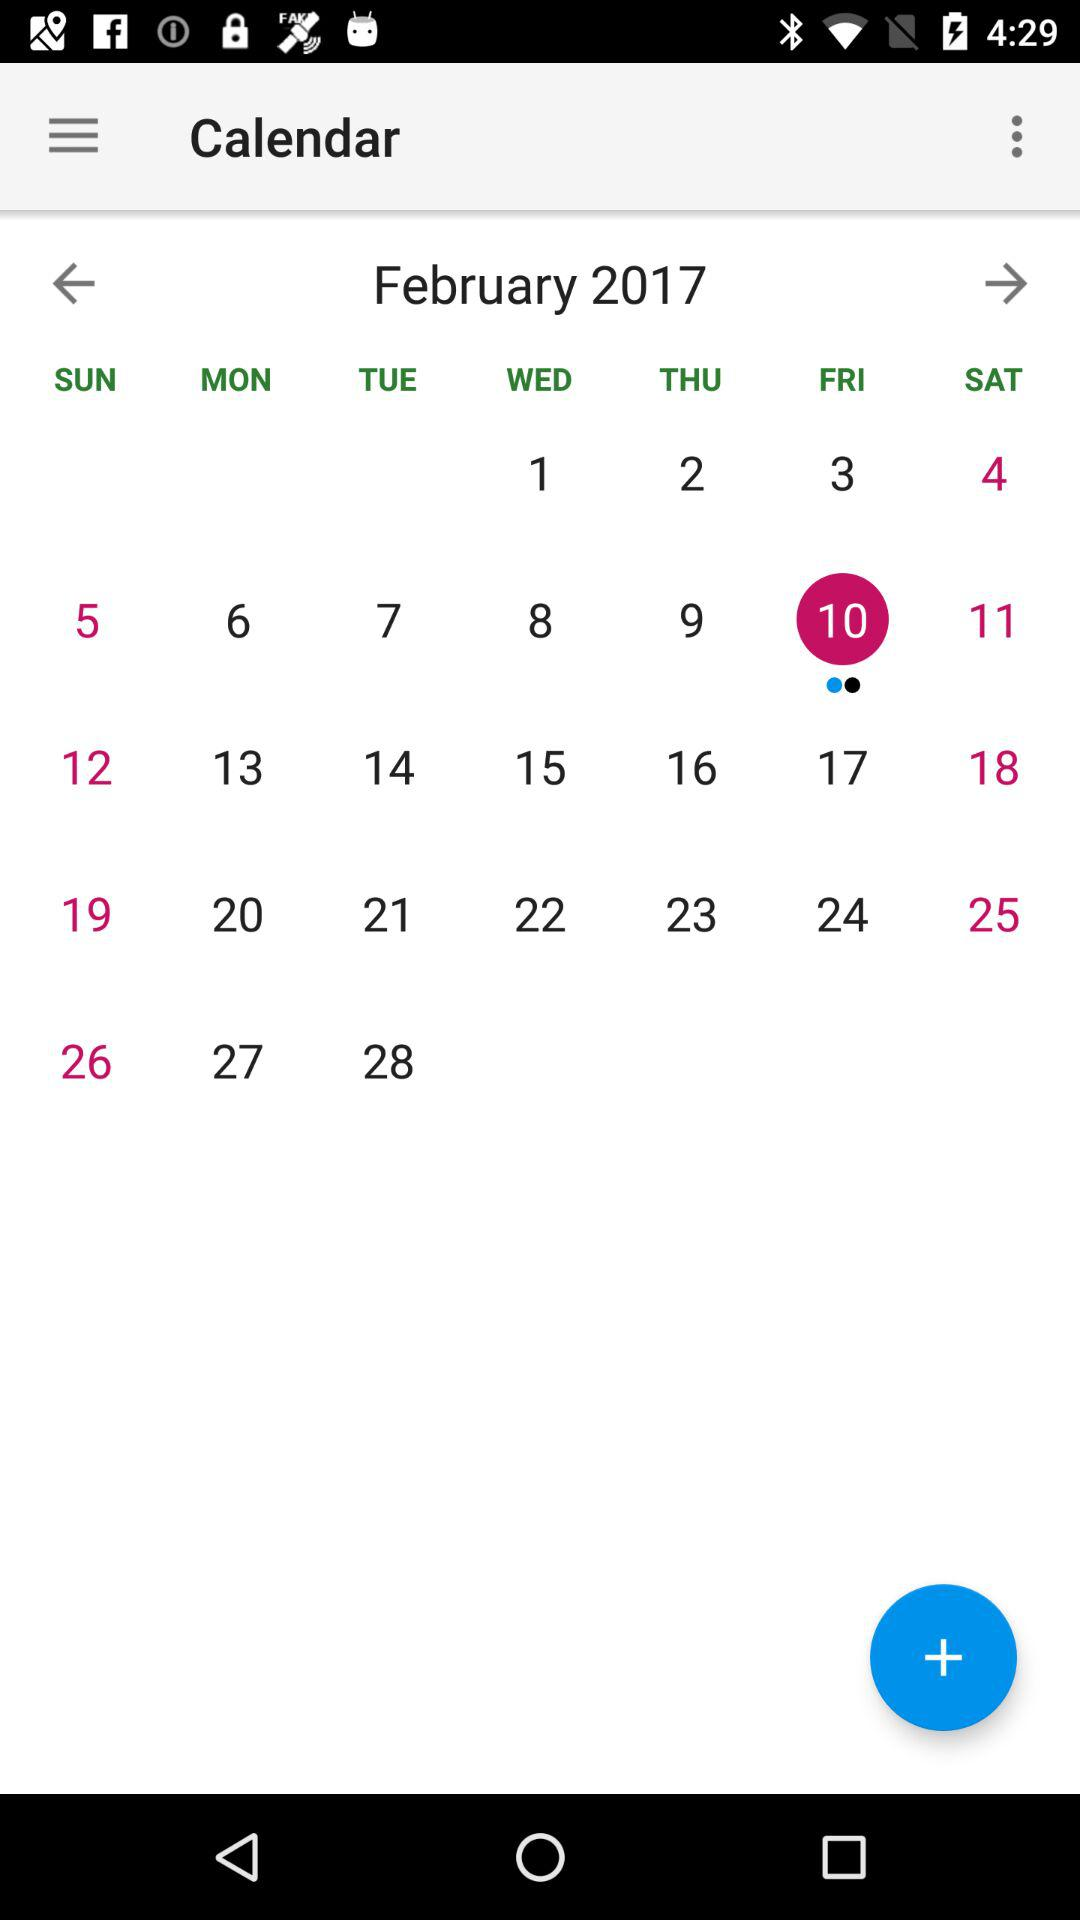What's the selected month and year? The selected month is February and the year is 2017. 